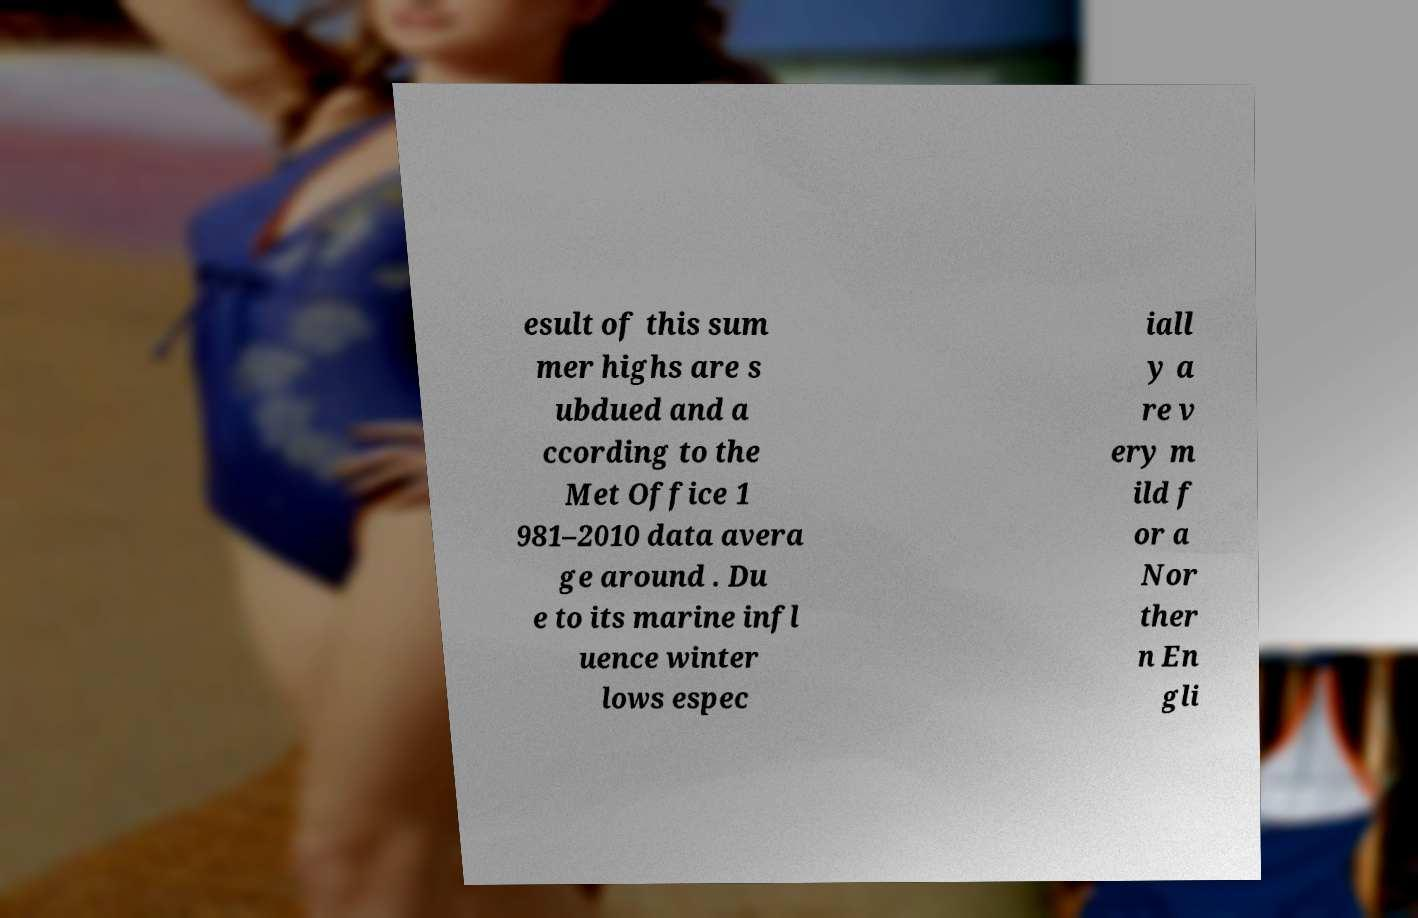For documentation purposes, I need the text within this image transcribed. Could you provide that? esult of this sum mer highs are s ubdued and a ccording to the Met Office 1 981–2010 data avera ge around . Du e to its marine infl uence winter lows espec iall y a re v ery m ild f or a Nor ther n En gli 